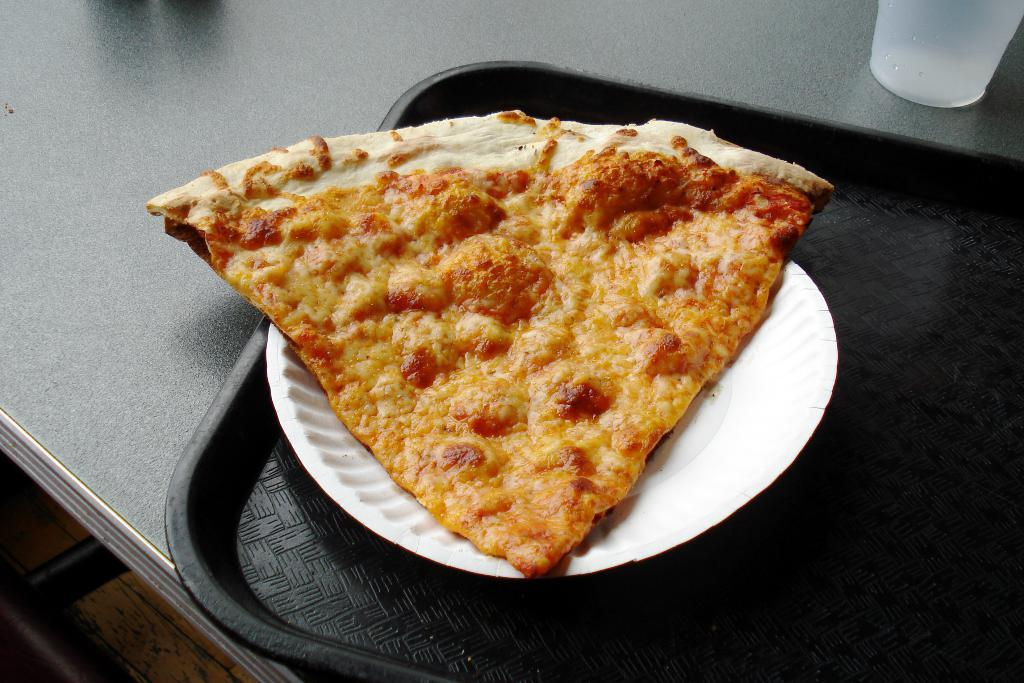What piece of furniture is present in the image? There is a table in the image. What is placed on the table? There is a plate on the table. What is on the plate? There is a food item on the plate. What type of container is visible in the image? There is a glass in the image. How many mice are running around on the table in the image? There are no mice present in the image; only a table, a plate, a food item, and a glass are visible. What type of flight is taking place in the image? There is no flight or any reference to flying objects in the image. 